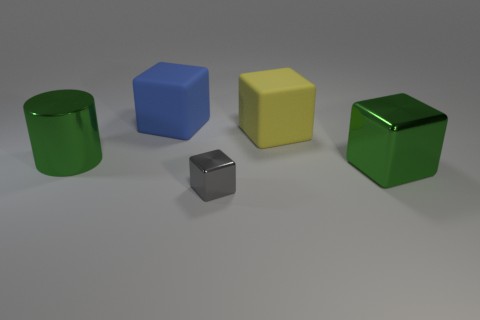The other rubber block that is the same size as the blue matte cube is what color?
Your answer should be compact. Yellow. Are there the same number of small gray metallic blocks that are behind the tiny metal thing and cubes?
Ensure brevity in your answer.  No. There is a thing left of the matte block that is on the left side of the big yellow block; what is its color?
Offer a very short reply. Green. There is a metal thing that is in front of the green thing that is to the right of the tiny gray cube; what size is it?
Provide a succinct answer. Small. What number of other things are there of the same size as the gray shiny cube?
Give a very brief answer. 0. There is a rubber thing that is right of the tiny gray metallic block that is in front of the big object that is left of the big blue rubber block; what is its color?
Make the answer very short. Yellow. What shape is the rubber thing to the right of the gray block?
Make the answer very short. Cube. Are there any matte cubes that are to the left of the cube in front of the green cube?
Give a very brief answer. Yes. The big thing that is both on the right side of the big green metal cylinder and to the left of the big yellow rubber cube is what color?
Give a very brief answer. Blue. There is a large green shiny object that is behind the large green object that is in front of the large cylinder; are there any large objects that are to the right of it?
Keep it short and to the point. Yes. 